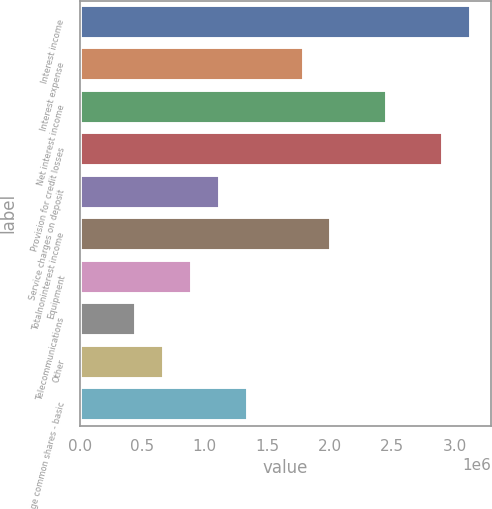Convert chart. <chart><loc_0><loc_0><loc_500><loc_500><bar_chart><fcel>Interest income<fcel>Interest expense<fcel>Net interest income<fcel>Provision for credit losses<fcel>Service charges on deposit<fcel>Totalnoninterest income<fcel>Equipment<fcel>Telecommunications<fcel>Other<fcel>Average common shares - basic<nl><fcel>3.1334e+06<fcel>1.79051e+06<fcel>2.46196e+06<fcel>2.90958e+06<fcel>1.11907e+06<fcel>2.01433e+06<fcel>895257<fcel>447628<fcel>671443<fcel>1.34289e+06<nl></chart> 